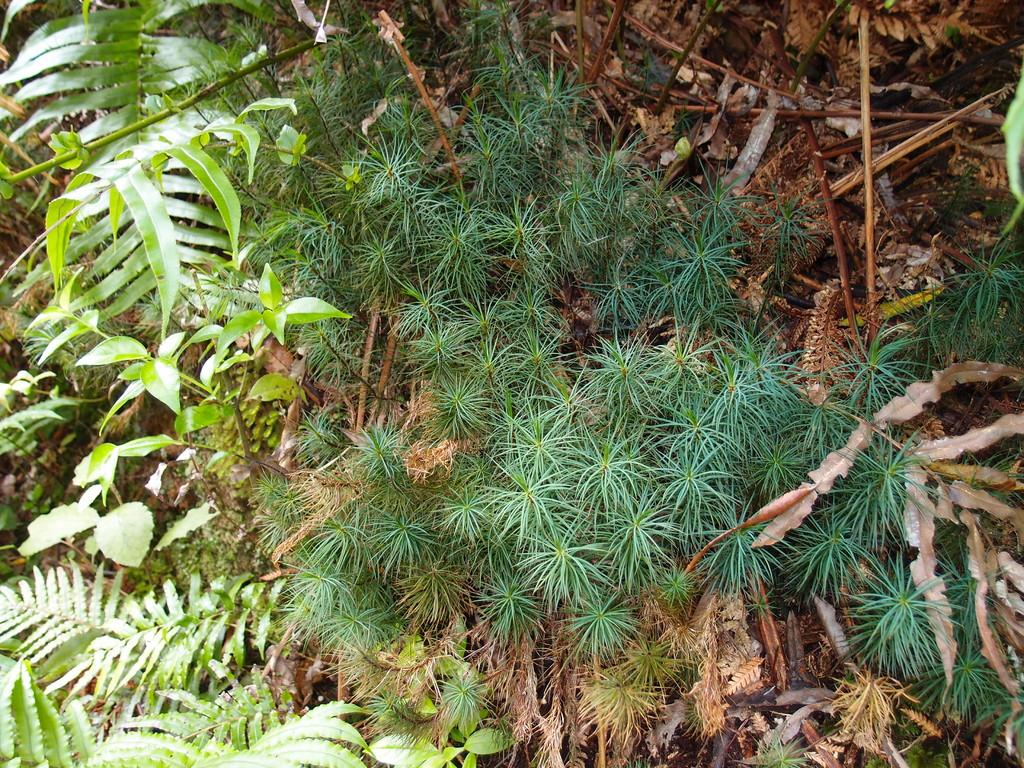What type of living organisms can be seen in the image? Plants can be seen in the image. What part of the plants is visible in the image? Leaves and plant saplings are visible in the image. What additional plant materials can be seen in the image? Dried twigs and sticks are present in the image. How many chickens are present in the image? There are no chickens present in the image; it features plants, leaves, plant saplings, and dried twigs and sticks. What type of shock can be seen in the image? There is no shock present in the image; it is a still image of plants and related materials. 